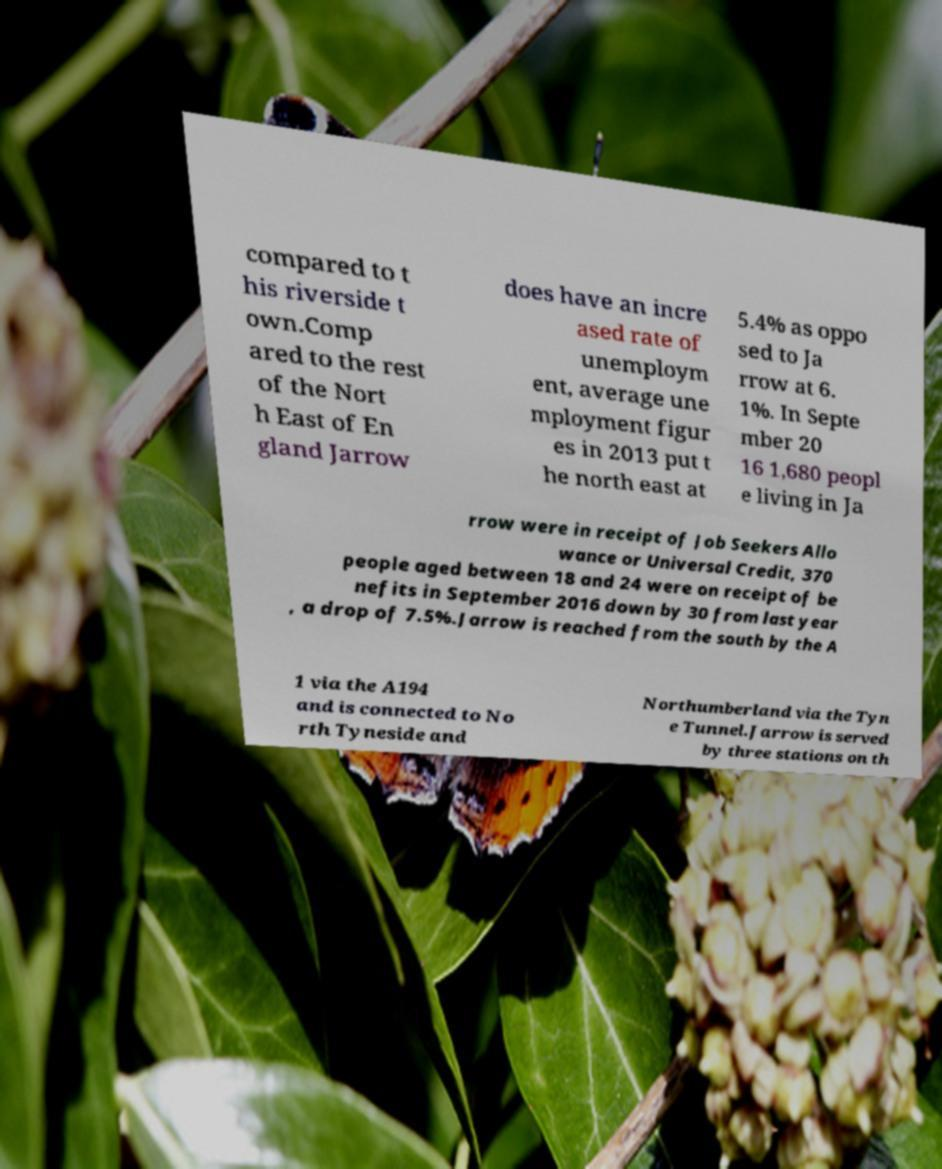Can you read and provide the text displayed in the image?This photo seems to have some interesting text. Can you extract and type it out for me? compared to t his riverside t own.Comp ared to the rest of the Nort h East of En gland Jarrow does have an incre ased rate of unemploym ent, average une mployment figur es in 2013 put t he north east at 5.4% as oppo sed to Ja rrow at 6. 1%. In Septe mber 20 16 1,680 peopl e living in Ja rrow were in receipt of Job Seekers Allo wance or Universal Credit, 370 people aged between 18 and 24 were on receipt of be nefits in September 2016 down by 30 from last year , a drop of 7.5%.Jarrow is reached from the south by the A 1 via the A194 and is connected to No rth Tyneside and Northumberland via the Tyn e Tunnel.Jarrow is served by three stations on th 